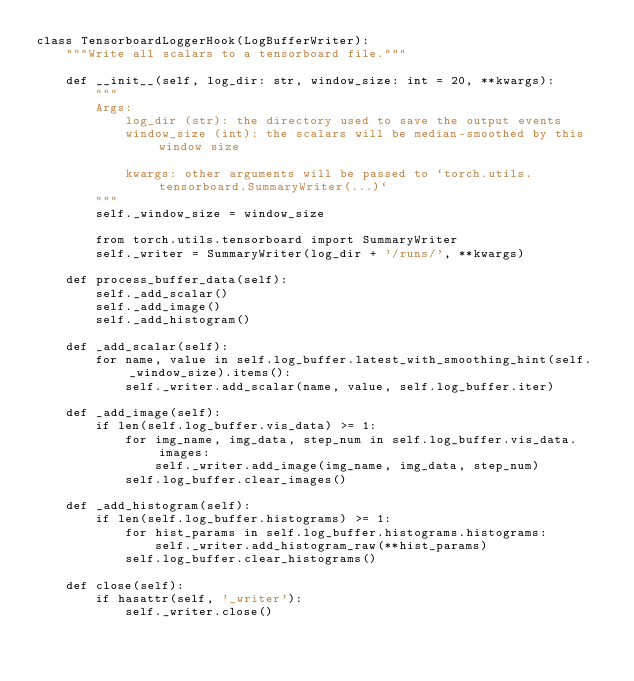Convert code to text. <code><loc_0><loc_0><loc_500><loc_500><_Python_>class TensorboardLoggerHook(LogBufferWriter):
    """Write all scalars to a tensorboard file."""

    def __init__(self, log_dir: str, window_size: int = 20, **kwargs):
        """
        Args:
            log_dir (str): the directory used to save the output events
            window_size (int): the scalars will be median-smoothed by this window size

            kwargs: other arguments will be passed to `torch.utils.tensorboard.SummaryWriter(...)`
        """
        self._window_size = window_size

        from torch.utils.tensorboard import SummaryWriter
        self._writer = SummaryWriter(log_dir + '/runs/', **kwargs)

    def process_buffer_data(self):
        self._add_scalar()
        self._add_image()
        self._add_histogram()

    def _add_scalar(self):
        for name, value in self.log_buffer.latest_with_smoothing_hint(self._window_size).items():
            self._writer.add_scalar(name, value, self.log_buffer.iter)

    def _add_image(self):
        if len(self.log_buffer.vis_data) >= 1:
            for img_name, img_data, step_num in self.log_buffer.vis_data.images:
                self._writer.add_image(img_name, img_data, step_num)
            self.log_buffer.clear_images()

    def _add_histogram(self):
        if len(self.log_buffer.histograms) >= 1:
            for hist_params in self.log_buffer.histograms.histograms:
                self._writer.add_histogram_raw(**hist_params)
            self.log_buffer.clear_histograms()

    def close(self):
        if hasattr(self, '_writer'):
            self._writer.close()
</code> 